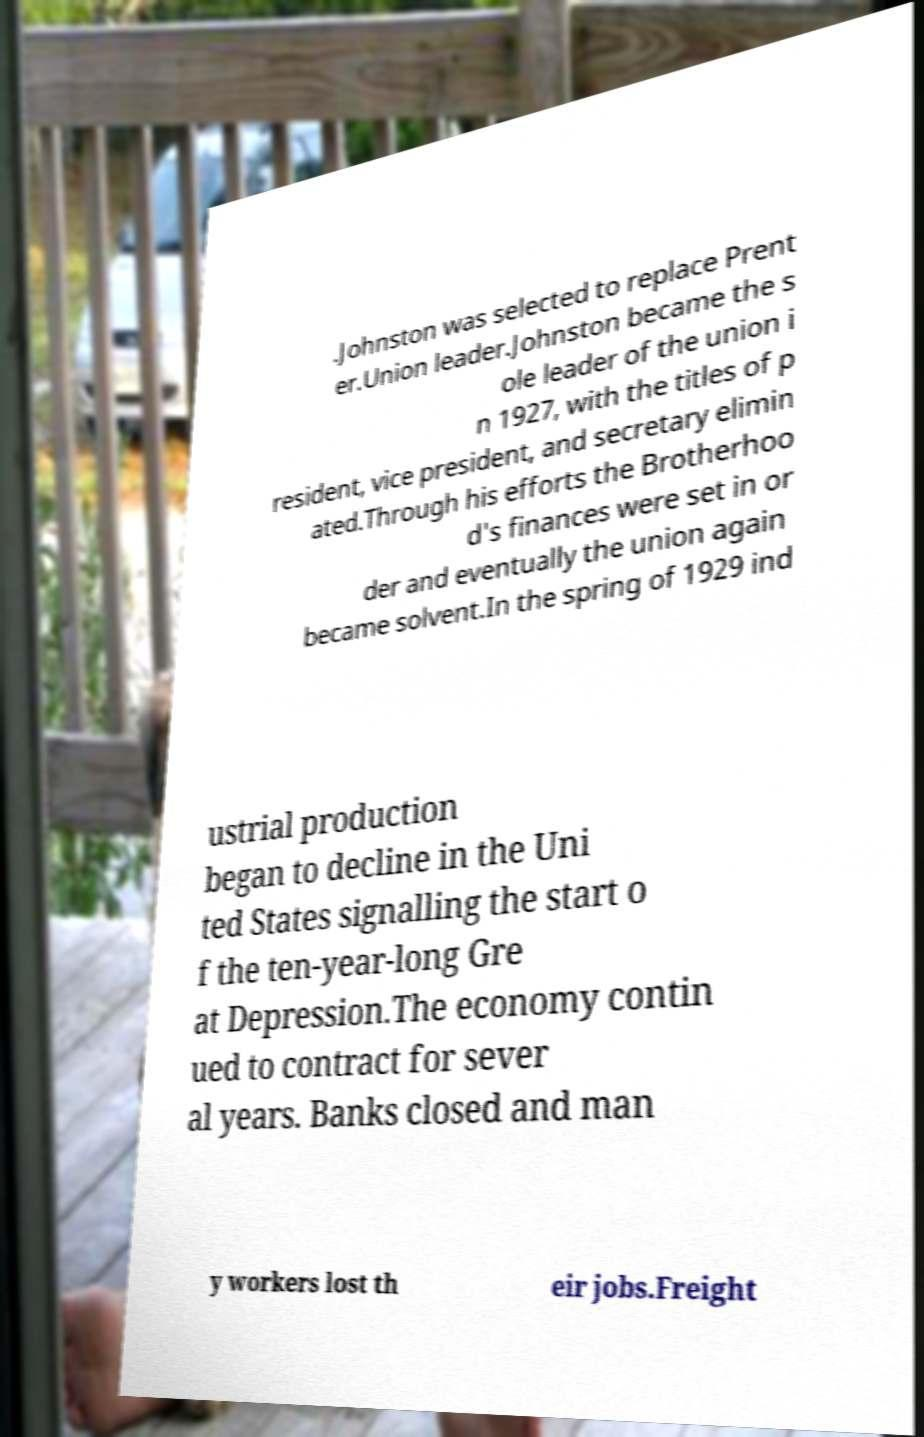I need the written content from this picture converted into text. Can you do that? .Johnston was selected to replace Prent er.Union leader.Johnston became the s ole leader of the union i n 1927, with the titles of p resident, vice president, and secretary elimin ated.Through his efforts the Brotherhoo d's finances were set in or der and eventually the union again became solvent.In the spring of 1929 ind ustrial production began to decline in the Uni ted States signalling the start o f the ten-year-long Gre at Depression.The economy contin ued to contract for sever al years. Banks closed and man y workers lost th eir jobs.Freight 